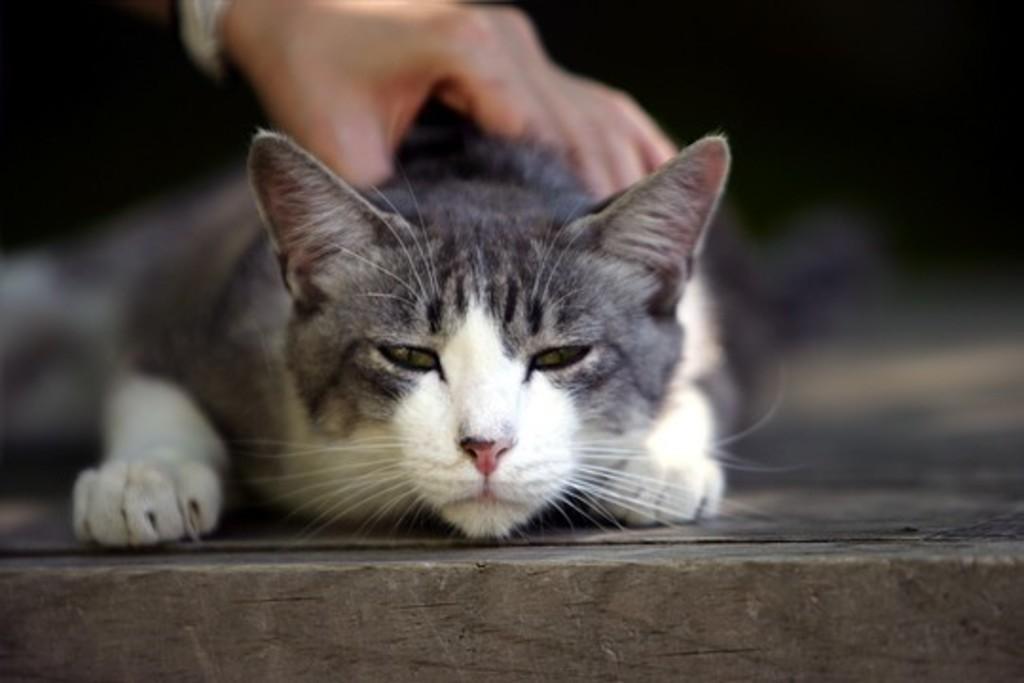Can you describe this image briefly? There is a cat in the center of the image on a wooden surface, there is a hand on it at the top side. 